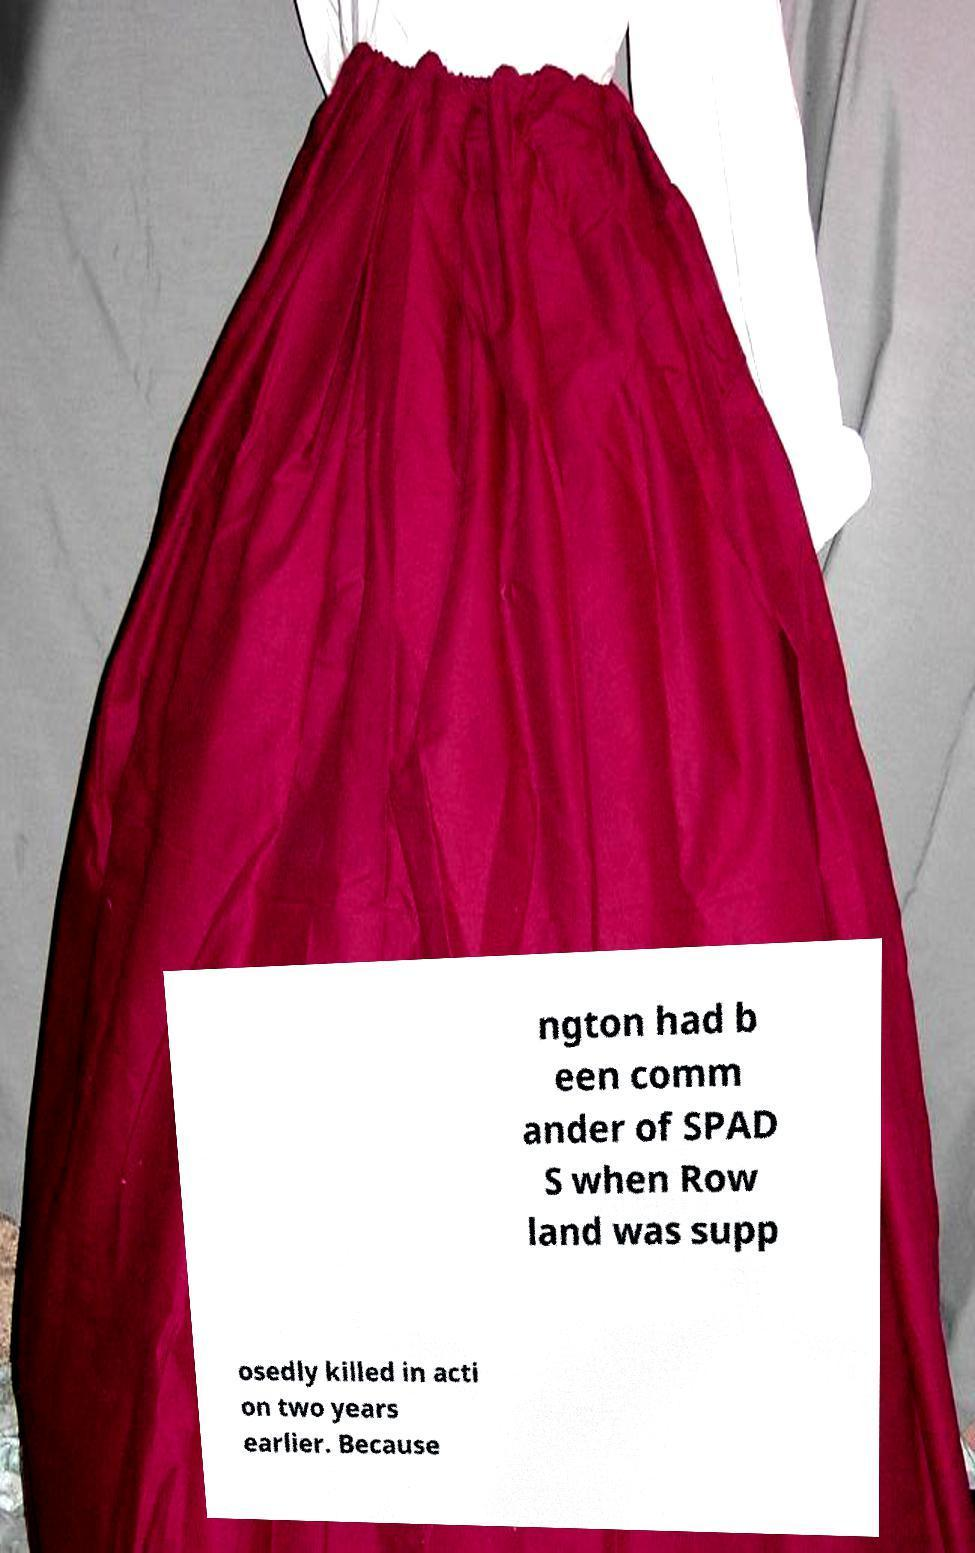I need the written content from this picture converted into text. Can you do that? ngton had b een comm ander of SPAD S when Row land was supp osedly killed in acti on two years earlier. Because 